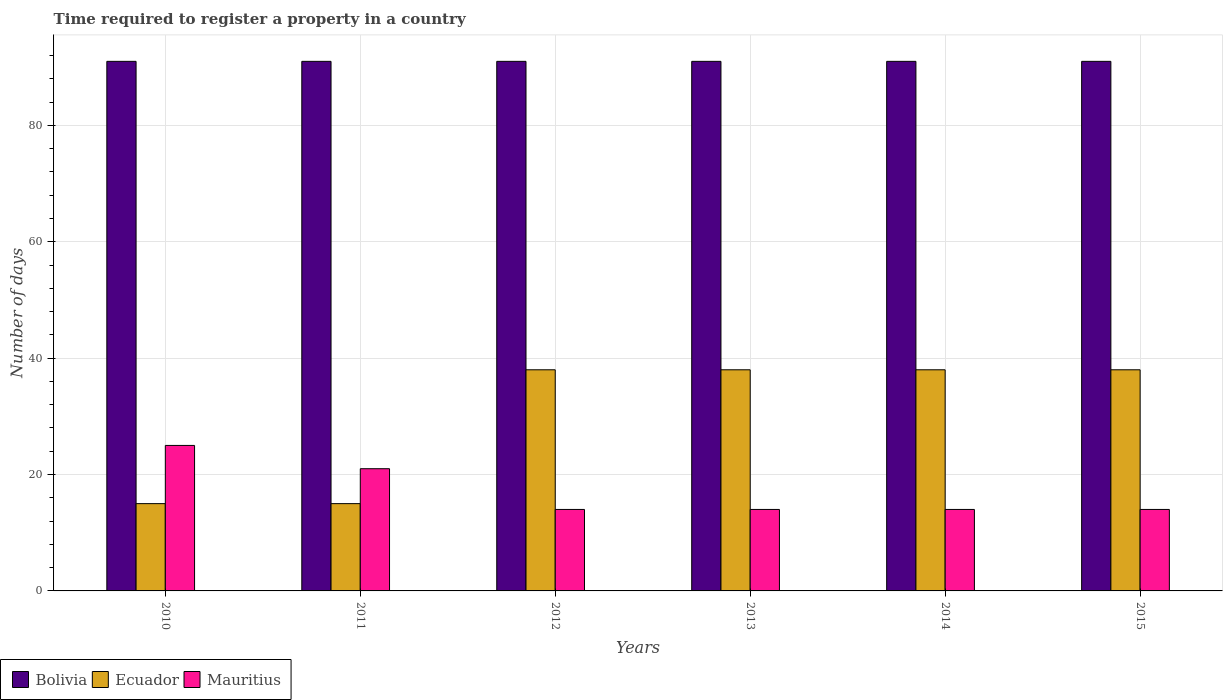How many groups of bars are there?
Make the answer very short. 6. Are the number of bars per tick equal to the number of legend labels?
Give a very brief answer. Yes. How many bars are there on the 5th tick from the left?
Your answer should be very brief. 3. How many bars are there on the 4th tick from the right?
Make the answer very short. 3. In how many cases, is the number of bars for a given year not equal to the number of legend labels?
Your response must be concise. 0. What is the number of days required to register a property in Ecuador in 2014?
Offer a terse response. 38. Across all years, what is the maximum number of days required to register a property in Mauritius?
Ensure brevity in your answer.  25. Across all years, what is the minimum number of days required to register a property in Mauritius?
Make the answer very short. 14. In which year was the number of days required to register a property in Mauritius maximum?
Provide a short and direct response. 2010. What is the total number of days required to register a property in Mauritius in the graph?
Offer a terse response. 102. What is the difference between the number of days required to register a property in Bolivia in 2010 and that in 2011?
Your response must be concise. 0. What is the difference between the number of days required to register a property in Ecuador in 2011 and the number of days required to register a property in Mauritius in 2015?
Your answer should be very brief. 1. What is the average number of days required to register a property in Ecuador per year?
Your response must be concise. 30.33. In the year 2015, what is the difference between the number of days required to register a property in Bolivia and number of days required to register a property in Ecuador?
Your answer should be compact. 53. What is the ratio of the number of days required to register a property in Mauritius in 2010 to that in 2015?
Your answer should be very brief. 1.79. Is the difference between the number of days required to register a property in Bolivia in 2012 and 2013 greater than the difference between the number of days required to register a property in Ecuador in 2012 and 2013?
Your response must be concise. No. What is the difference between the highest and the second highest number of days required to register a property in Mauritius?
Keep it short and to the point. 4. In how many years, is the number of days required to register a property in Mauritius greater than the average number of days required to register a property in Mauritius taken over all years?
Your response must be concise. 2. Is the sum of the number of days required to register a property in Ecuador in 2013 and 2014 greater than the maximum number of days required to register a property in Mauritius across all years?
Your response must be concise. Yes. What does the 1st bar from the left in 2013 represents?
Your response must be concise. Bolivia. What does the 1st bar from the right in 2012 represents?
Provide a succinct answer. Mauritius. Is it the case that in every year, the sum of the number of days required to register a property in Mauritius and number of days required to register a property in Ecuador is greater than the number of days required to register a property in Bolivia?
Your answer should be compact. No. How many bars are there?
Make the answer very short. 18. Are all the bars in the graph horizontal?
Your response must be concise. No. How many years are there in the graph?
Your answer should be very brief. 6. Are the values on the major ticks of Y-axis written in scientific E-notation?
Keep it short and to the point. No. Does the graph contain any zero values?
Ensure brevity in your answer.  No. How many legend labels are there?
Give a very brief answer. 3. What is the title of the graph?
Provide a succinct answer. Time required to register a property in a country. What is the label or title of the X-axis?
Give a very brief answer. Years. What is the label or title of the Y-axis?
Make the answer very short. Number of days. What is the Number of days of Bolivia in 2010?
Your answer should be compact. 91. What is the Number of days of Ecuador in 2010?
Offer a very short reply. 15. What is the Number of days in Bolivia in 2011?
Your response must be concise. 91. What is the Number of days of Mauritius in 2011?
Offer a very short reply. 21. What is the Number of days of Bolivia in 2012?
Your answer should be compact. 91. What is the Number of days of Bolivia in 2013?
Give a very brief answer. 91. What is the Number of days of Bolivia in 2014?
Keep it short and to the point. 91. What is the Number of days in Ecuador in 2014?
Keep it short and to the point. 38. What is the Number of days in Bolivia in 2015?
Your answer should be very brief. 91. What is the Number of days of Ecuador in 2015?
Offer a terse response. 38. What is the Number of days of Mauritius in 2015?
Make the answer very short. 14. Across all years, what is the maximum Number of days in Bolivia?
Your answer should be very brief. 91. Across all years, what is the maximum Number of days of Ecuador?
Keep it short and to the point. 38. Across all years, what is the minimum Number of days in Bolivia?
Give a very brief answer. 91. What is the total Number of days of Bolivia in the graph?
Provide a succinct answer. 546. What is the total Number of days of Ecuador in the graph?
Your answer should be very brief. 182. What is the total Number of days in Mauritius in the graph?
Provide a short and direct response. 102. What is the difference between the Number of days of Mauritius in 2010 and that in 2011?
Give a very brief answer. 4. What is the difference between the Number of days in Bolivia in 2010 and that in 2013?
Ensure brevity in your answer.  0. What is the difference between the Number of days in Ecuador in 2010 and that in 2013?
Offer a terse response. -23. What is the difference between the Number of days of Bolivia in 2010 and that in 2014?
Provide a succinct answer. 0. What is the difference between the Number of days in Ecuador in 2010 and that in 2014?
Ensure brevity in your answer.  -23. What is the difference between the Number of days of Mauritius in 2010 and that in 2014?
Your answer should be very brief. 11. What is the difference between the Number of days of Bolivia in 2010 and that in 2015?
Give a very brief answer. 0. What is the difference between the Number of days in Ecuador in 2010 and that in 2015?
Offer a terse response. -23. What is the difference between the Number of days of Mauritius in 2010 and that in 2015?
Your answer should be very brief. 11. What is the difference between the Number of days in Bolivia in 2011 and that in 2012?
Your answer should be compact. 0. What is the difference between the Number of days of Ecuador in 2011 and that in 2012?
Your response must be concise. -23. What is the difference between the Number of days in Bolivia in 2011 and that in 2014?
Your answer should be very brief. 0. What is the difference between the Number of days of Bolivia in 2011 and that in 2015?
Give a very brief answer. 0. What is the difference between the Number of days in Ecuador in 2011 and that in 2015?
Provide a succinct answer. -23. What is the difference between the Number of days in Mauritius in 2011 and that in 2015?
Your response must be concise. 7. What is the difference between the Number of days in Mauritius in 2012 and that in 2013?
Your answer should be very brief. 0. What is the difference between the Number of days of Bolivia in 2012 and that in 2014?
Provide a succinct answer. 0. What is the difference between the Number of days in Ecuador in 2012 and that in 2014?
Offer a terse response. 0. What is the difference between the Number of days in Mauritius in 2012 and that in 2014?
Offer a very short reply. 0. What is the difference between the Number of days in Bolivia in 2013 and that in 2014?
Offer a very short reply. 0. What is the difference between the Number of days in Ecuador in 2013 and that in 2014?
Offer a terse response. 0. What is the difference between the Number of days of Mauritius in 2013 and that in 2014?
Give a very brief answer. 0. What is the difference between the Number of days of Bolivia in 2013 and that in 2015?
Provide a succinct answer. 0. What is the difference between the Number of days in Bolivia in 2014 and that in 2015?
Keep it short and to the point. 0. What is the difference between the Number of days in Ecuador in 2014 and that in 2015?
Your response must be concise. 0. What is the difference between the Number of days of Bolivia in 2010 and the Number of days of Ecuador in 2011?
Offer a very short reply. 76. What is the difference between the Number of days of Ecuador in 2010 and the Number of days of Mauritius in 2011?
Make the answer very short. -6. What is the difference between the Number of days of Bolivia in 2010 and the Number of days of Mauritius in 2012?
Offer a very short reply. 77. What is the difference between the Number of days of Bolivia in 2010 and the Number of days of Mauritius in 2013?
Your response must be concise. 77. What is the difference between the Number of days of Ecuador in 2010 and the Number of days of Mauritius in 2013?
Provide a short and direct response. 1. What is the difference between the Number of days in Bolivia in 2010 and the Number of days in Ecuador in 2015?
Offer a terse response. 53. What is the difference between the Number of days of Bolivia in 2010 and the Number of days of Mauritius in 2015?
Provide a succinct answer. 77. What is the difference between the Number of days in Ecuador in 2010 and the Number of days in Mauritius in 2015?
Your answer should be very brief. 1. What is the difference between the Number of days in Bolivia in 2011 and the Number of days in Mauritius in 2012?
Keep it short and to the point. 77. What is the difference between the Number of days of Ecuador in 2011 and the Number of days of Mauritius in 2012?
Keep it short and to the point. 1. What is the difference between the Number of days of Ecuador in 2011 and the Number of days of Mauritius in 2013?
Your answer should be compact. 1. What is the difference between the Number of days in Bolivia in 2011 and the Number of days in Ecuador in 2015?
Offer a terse response. 53. What is the difference between the Number of days in Bolivia in 2011 and the Number of days in Mauritius in 2015?
Make the answer very short. 77. What is the difference between the Number of days of Bolivia in 2012 and the Number of days of Ecuador in 2013?
Your response must be concise. 53. What is the difference between the Number of days in Ecuador in 2012 and the Number of days in Mauritius in 2013?
Ensure brevity in your answer.  24. What is the difference between the Number of days in Bolivia in 2012 and the Number of days in Ecuador in 2014?
Ensure brevity in your answer.  53. What is the difference between the Number of days in Bolivia in 2012 and the Number of days in Mauritius in 2014?
Your answer should be compact. 77. What is the difference between the Number of days of Ecuador in 2012 and the Number of days of Mauritius in 2014?
Offer a terse response. 24. What is the difference between the Number of days of Bolivia in 2012 and the Number of days of Ecuador in 2015?
Your answer should be very brief. 53. What is the difference between the Number of days of Ecuador in 2012 and the Number of days of Mauritius in 2015?
Your response must be concise. 24. What is the difference between the Number of days in Ecuador in 2013 and the Number of days in Mauritius in 2015?
Ensure brevity in your answer.  24. What is the difference between the Number of days in Bolivia in 2014 and the Number of days in Mauritius in 2015?
Your answer should be compact. 77. What is the difference between the Number of days of Ecuador in 2014 and the Number of days of Mauritius in 2015?
Offer a very short reply. 24. What is the average Number of days in Bolivia per year?
Your response must be concise. 91. What is the average Number of days in Ecuador per year?
Keep it short and to the point. 30.33. In the year 2010, what is the difference between the Number of days of Bolivia and Number of days of Ecuador?
Make the answer very short. 76. In the year 2010, what is the difference between the Number of days of Bolivia and Number of days of Mauritius?
Make the answer very short. 66. In the year 2011, what is the difference between the Number of days of Bolivia and Number of days of Ecuador?
Your answer should be compact. 76. In the year 2012, what is the difference between the Number of days in Bolivia and Number of days in Mauritius?
Offer a very short reply. 77. In the year 2014, what is the difference between the Number of days of Bolivia and Number of days of Ecuador?
Keep it short and to the point. 53. In the year 2014, what is the difference between the Number of days of Bolivia and Number of days of Mauritius?
Offer a very short reply. 77. In the year 2014, what is the difference between the Number of days in Ecuador and Number of days in Mauritius?
Give a very brief answer. 24. What is the ratio of the Number of days in Bolivia in 2010 to that in 2011?
Provide a succinct answer. 1. What is the ratio of the Number of days of Ecuador in 2010 to that in 2011?
Make the answer very short. 1. What is the ratio of the Number of days of Mauritius in 2010 to that in 2011?
Offer a very short reply. 1.19. What is the ratio of the Number of days of Bolivia in 2010 to that in 2012?
Give a very brief answer. 1. What is the ratio of the Number of days in Ecuador in 2010 to that in 2012?
Your response must be concise. 0.39. What is the ratio of the Number of days of Mauritius in 2010 to that in 2012?
Give a very brief answer. 1.79. What is the ratio of the Number of days in Bolivia in 2010 to that in 2013?
Your answer should be compact. 1. What is the ratio of the Number of days of Ecuador in 2010 to that in 2013?
Give a very brief answer. 0.39. What is the ratio of the Number of days in Mauritius in 2010 to that in 2013?
Give a very brief answer. 1.79. What is the ratio of the Number of days in Bolivia in 2010 to that in 2014?
Ensure brevity in your answer.  1. What is the ratio of the Number of days in Ecuador in 2010 to that in 2014?
Give a very brief answer. 0.39. What is the ratio of the Number of days of Mauritius in 2010 to that in 2014?
Keep it short and to the point. 1.79. What is the ratio of the Number of days in Ecuador in 2010 to that in 2015?
Your answer should be very brief. 0.39. What is the ratio of the Number of days of Mauritius in 2010 to that in 2015?
Your response must be concise. 1.79. What is the ratio of the Number of days in Bolivia in 2011 to that in 2012?
Your answer should be compact. 1. What is the ratio of the Number of days in Ecuador in 2011 to that in 2012?
Ensure brevity in your answer.  0.39. What is the ratio of the Number of days in Mauritius in 2011 to that in 2012?
Give a very brief answer. 1.5. What is the ratio of the Number of days in Bolivia in 2011 to that in 2013?
Your answer should be compact. 1. What is the ratio of the Number of days in Ecuador in 2011 to that in 2013?
Provide a succinct answer. 0.39. What is the ratio of the Number of days in Bolivia in 2011 to that in 2014?
Ensure brevity in your answer.  1. What is the ratio of the Number of days in Ecuador in 2011 to that in 2014?
Offer a terse response. 0.39. What is the ratio of the Number of days of Ecuador in 2011 to that in 2015?
Provide a succinct answer. 0.39. What is the ratio of the Number of days of Mauritius in 2011 to that in 2015?
Give a very brief answer. 1.5. What is the ratio of the Number of days of Mauritius in 2012 to that in 2013?
Your answer should be very brief. 1. What is the ratio of the Number of days in Bolivia in 2012 to that in 2014?
Give a very brief answer. 1. What is the ratio of the Number of days in Mauritius in 2012 to that in 2014?
Provide a succinct answer. 1. What is the ratio of the Number of days in Bolivia in 2012 to that in 2015?
Your answer should be very brief. 1. What is the ratio of the Number of days of Mauritius in 2012 to that in 2015?
Your answer should be very brief. 1. What is the ratio of the Number of days of Bolivia in 2013 to that in 2014?
Your answer should be compact. 1. What is the ratio of the Number of days of Ecuador in 2013 to that in 2014?
Give a very brief answer. 1. What is the ratio of the Number of days in Bolivia in 2013 to that in 2015?
Keep it short and to the point. 1. What is the ratio of the Number of days of Mauritius in 2013 to that in 2015?
Keep it short and to the point. 1. What is the ratio of the Number of days of Mauritius in 2014 to that in 2015?
Ensure brevity in your answer.  1. What is the difference between the highest and the second highest Number of days of Bolivia?
Offer a terse response. 0. What is the difference between the highest and the lowest Number of days of Bolivia?
Offer a terse response. 0. What is the difference between the highest and the lowest Number of days in Mauritius?
Your answer should be very brief. 11. 